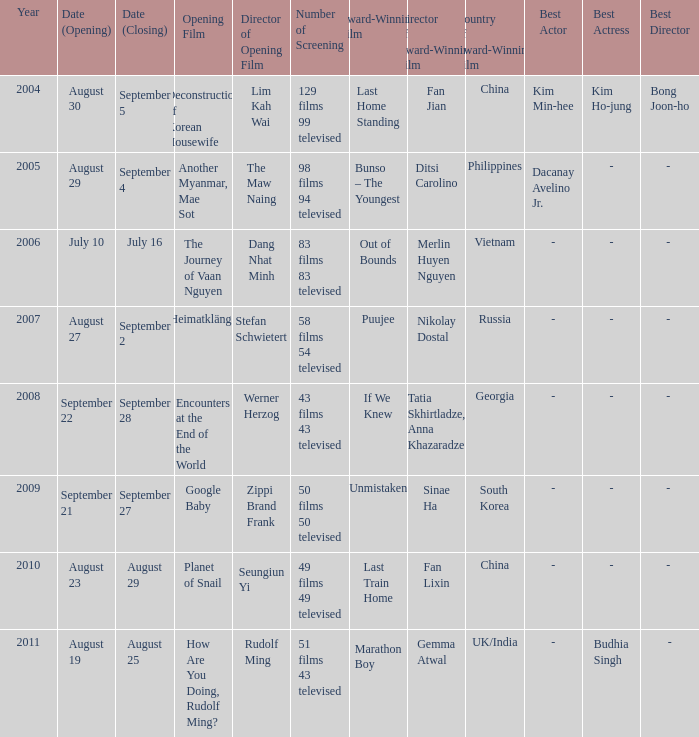Which acclaimed movie has a screening count of 50 films and 50 televised? Unmistaken. 